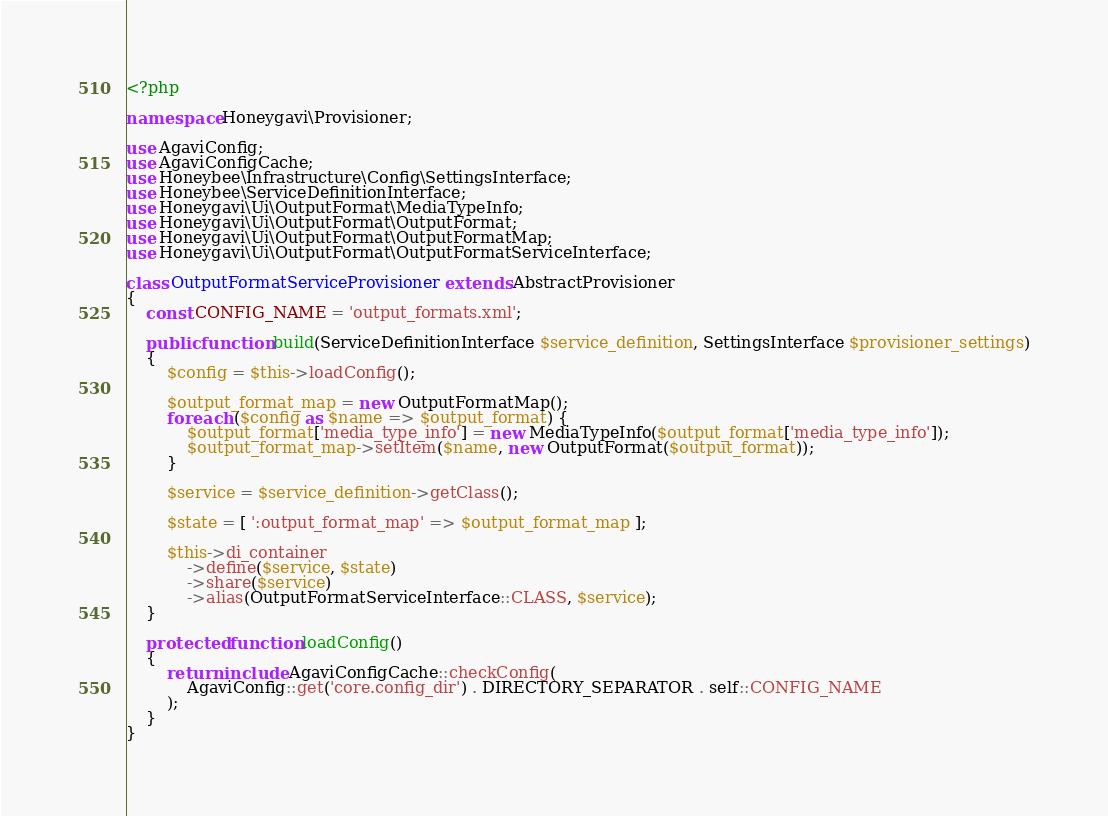Convert code to text. <code><loc_0><loc_0><loc_500><loc_500><_PHP_><?php

namespace Honeygavi\Provisioner;

use AgaviConfig;
use AgaviConfigCache;
use Honeybee\Infrastructure\Config\SettingsInterface;
use Honeybee\ServiceDefinitionInterface;
use Honeygavi\Ui\OutputFormat\MediaTypeInfo;
use Honeygavi\Ui\OutputFormat\OutputFormat;
use Honeygavi\Ui\OutputFormat\OutputFormatMap;
use Honeygavi\Ui\OutputFormat\OutputFormatServiceInterface;

class OutputFormatServiceProvisioner extends AbstractProvisioner
{
    const CONFIG_NAME = 'output_formats.xml';

    public function build(ServiceDefinitionInterface $service_definition, SettingsInterface $provisioner_settings)
    {
        $config = $this->loadConfig();

        $output_format_map = new OutputFormatMap();
        foreach ($config as $name => $output_format) {
            $output_format['media_type_info'] = new MediaTypeInfo($output_format['media_type_info']);
            $output_format_map->setItem($name, new OutputFormat($output_format));
        }

        $service = $service_definition->getClass();

        $state = [ ':output_format_map' => $output_format_map ];

        $this->di_container
            ->define($service, $state)
            ->share($service)
            ->alias(OutputFormatServiceInterface::CLASS, $service);
    }

    protected function loadConfig()
    {
        return include AgaviConfigCache::checkConfig(
            AgaviConfig::get('core.config_dir') . DIRECTORY_SEPARATOR . self::CONFIG_NAME
        );
    }
}
</code> 